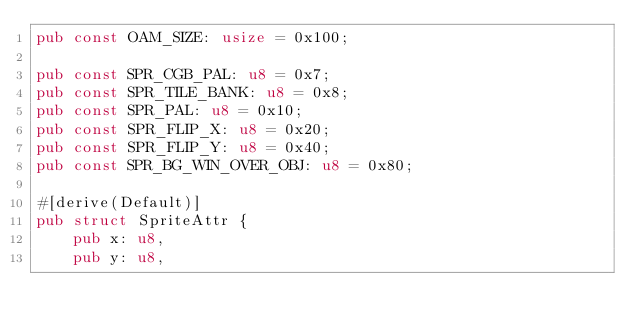Convert code to text. <code><loc_0><loc_0><loc_500><loc_500><_Rust_>pub const OAM_SIZE: usize = 0x100;

pub const SPR_CGB_PAL: u8 = 0x7;
pub const SPR_TILE_BANK: u8 = 0x8;
pub const SPR_PAL: u8 = 0x10;
pub const SPR_FLIP_X: u8 = 0x20;
pub const SPR_FLIP_Y: u8 = 0x40;
pub const SPR_BG_WIN_OVER_OBJ: u8 = 0x80;

#[derive(Default)]
pub struct SpriteAttr {
    pub x: u8,
    pub y: u8,</code> 